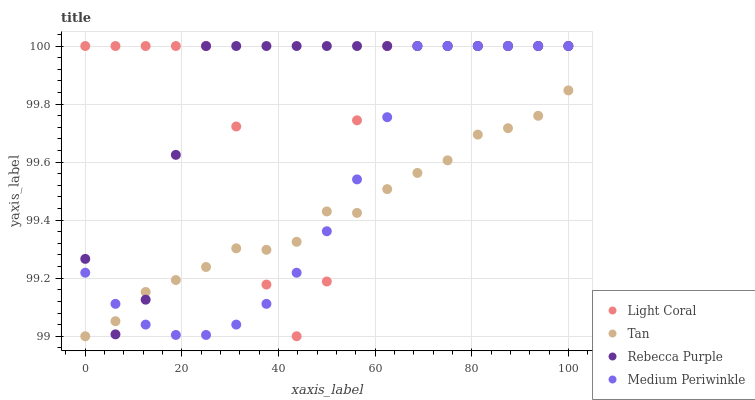Does Tan have the minimum area under the curve?
Answer yes or no. Yes. Does Rebecca Purple have the maximum area under the curve?
Answer yes or no. Yes. Does Medium Periwinkle have the minimum area under the curve?
Answer yes or no. No. Does Medium Periwinkle have the maximum area under the curve?
Answer yes or no. No. Is Medium Periwinkle the smoothest?
Answer yes or no. Yes. Is Light Coral the roughest?
Answer yes or no. Yes. Is Tan the smoothest?
Answer yes or no. No. Is Tan the roughest?
Answer yes or no. No. Does Tan have the lowest value?
Answer yes or no. Yes. Does Medium Periwinkle have the lowest value?
Answer yes or no. No. Does Rebecca Purple have the highest value?
Answer yes or no. Yes. Does Tan have the highest value?
Answer yes or no. No. Does Rebecca Purple intersect Light Coral?
Answer yes or no. Yes. Is Rebecca Purple less than Light Coral?
Answer yes or no. No. Is Rebecca Purple greater than Light Coral?
Answer yes or no. No. 